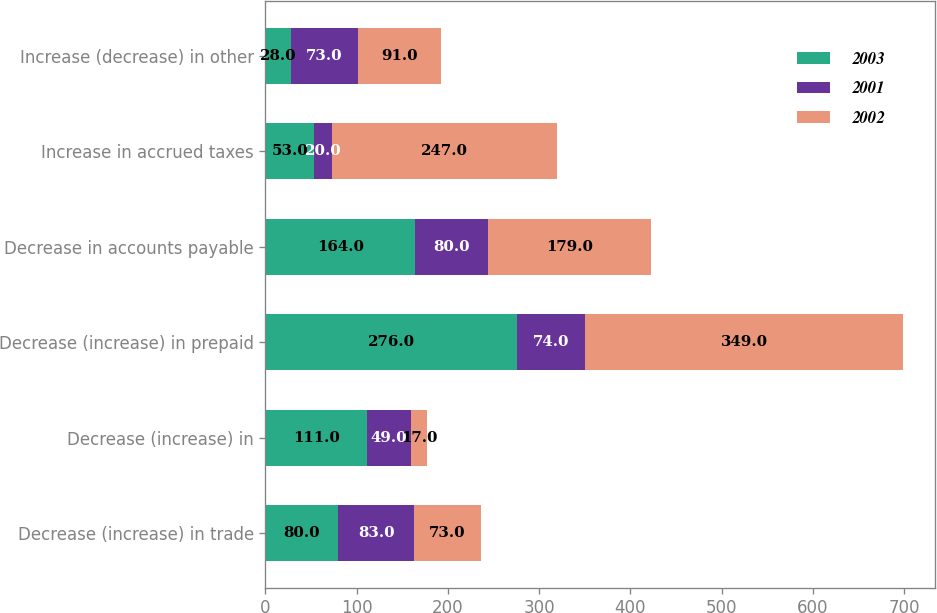Convert chart to OTSL. <chart><loc_0><loc_0><loc_500><loc_500><stacked_bar_chart><ecel><fcel>Decrease (increase) in trade<fcel>Decrease (increase) in<fcel>Decrease (increase) in prepaid<fcel>Decrease in accounts payable<fcel>Increase in accrued taxes<fcel>Increase (decrease) in other<nl><fcel>2003<fcel>80<fcel>111<fcel>276<fcel>164<fcel>53<fcel>28<nl><fcel>2001<fcel>83<fcel>49<fcel>74<fcel>80<fcel>20<fcel>73<nl><fcel>2002<fcel>73<fcel>17<fcel>349<fcel>179<fcel>247<fcel>91<nl></chart> 